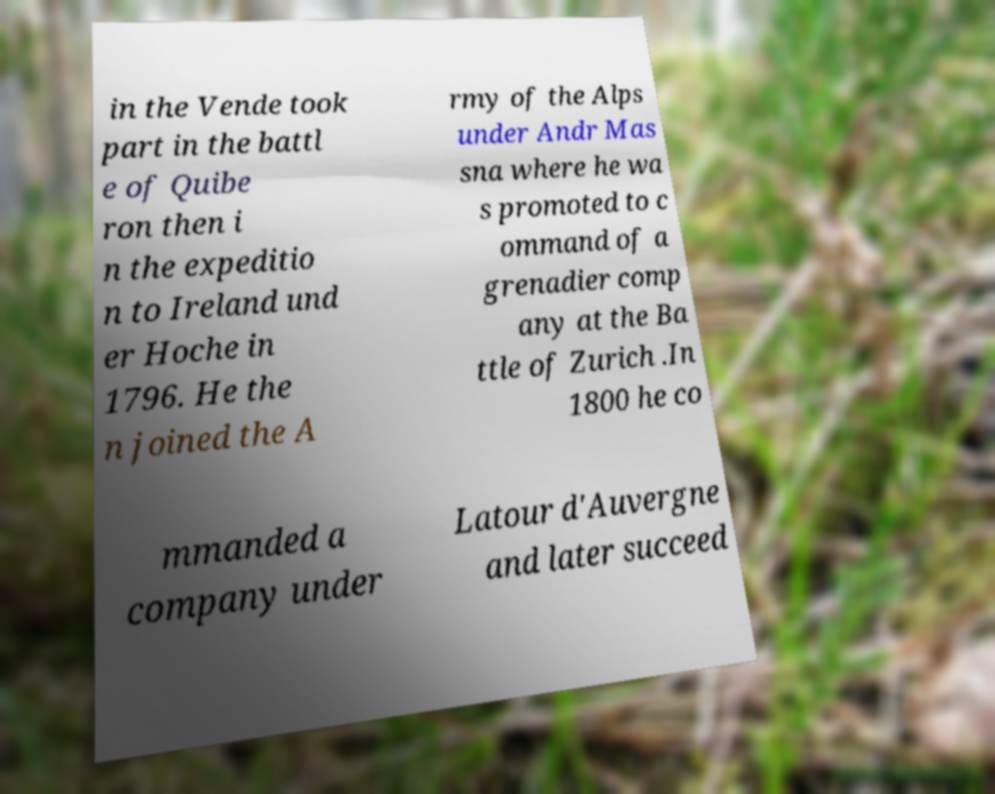There's text embedded in this image that I need extracted. Can you transcribe it verbatim? in the Vende took part in the battl e of Quibe ron then i n the expeditio n to Ireland und er Hoche in 1796. He the n joined the A rmy of the Alps under Andr Mas sna where he wa s promoted to c ommand of a grenadier comp any at the Ba ttle of Zurich .In 1800 he co mmanded a company under Latour d'Auvergne and later succeed 